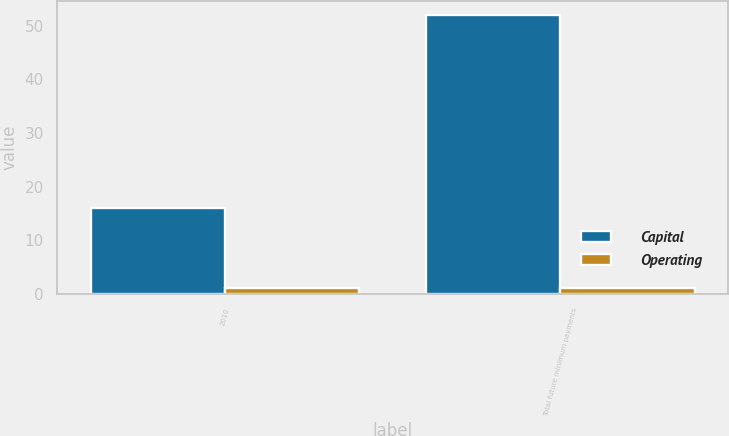Convert chart to OTSL. <chart><loc_0><loc_0><loc_500><loc_500><stacked_bar_chart><ecel><fcel>2010<fcel>Total future minimum payments<nl><fcel>Capital<fcel>16<fcel>52<nl><fcel>Operating<fcel>1<fcel>1<nl></chart> 